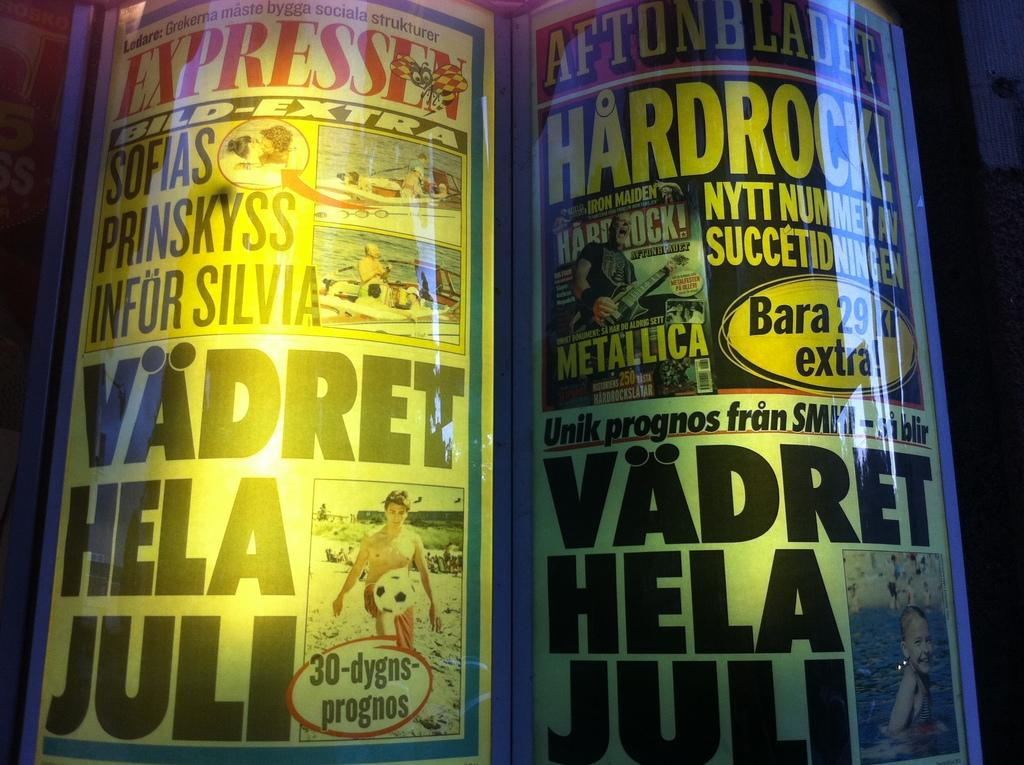What can be seen on the posters in the image? The posters in the image contain text and images. Can you describe the content of the posters? Unfortunately, the specific content of the posters cannot be determined from the provided facts. Is there a woman holding a lamp in the image? There is no mention of a woman or a lamp in the provided facts, so we cannot determine if they are present in the image. 